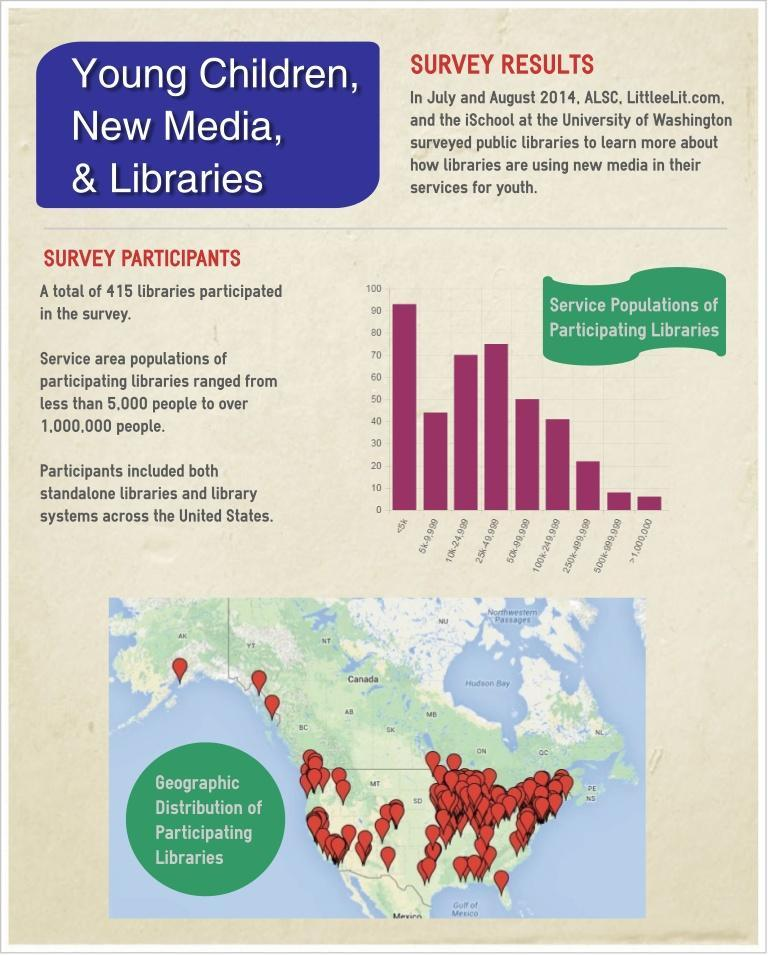What is the population of the library which has achieved second highest position in the survey?
Answer the question with a short phrase. 25k-49,999 What is the population of the library which has achieved third highest position in the survey? 10k-24,999 Which part of the United States has more participation in the survey- North, South, West, East? East 